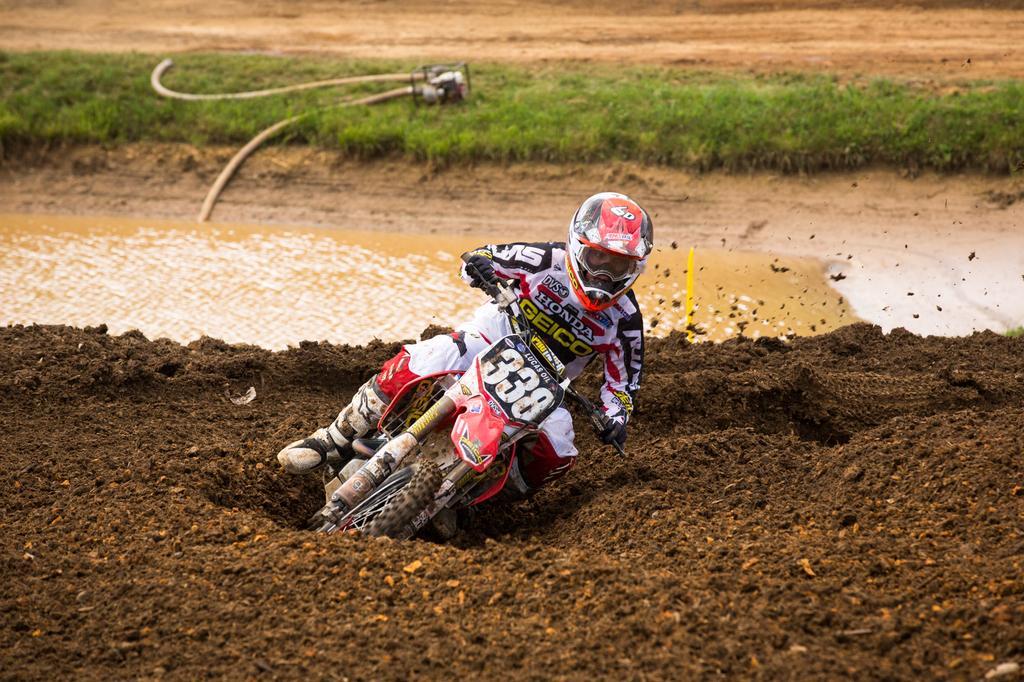Please provide a concise description of this image. In this image I can see a person wearing white, red and black colored dress and white, red and black colored helmet is riding a motor bike which is white , black and red in color on the mud which is brown in color. In the background I can see some grass, the water, few pipes and a motor. 